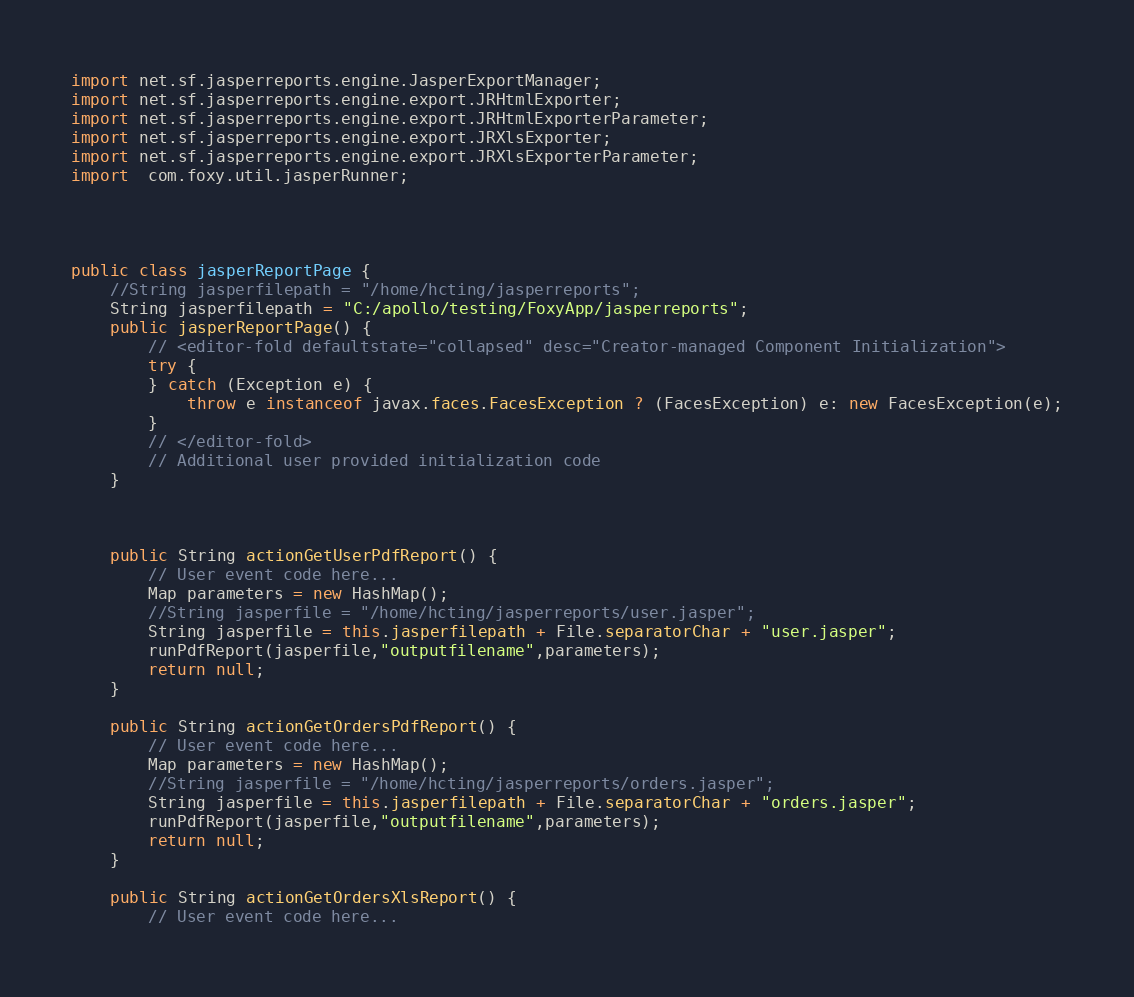<code> <loc_0><loc_0><loc_500><loc_500><_Java_>
import net.sf.jasperreports.engine.JasperExportManager;
import net.sf.jasperreports.engine.export.JRHtmlExporter;
import net.sf.jasperreports.engine.export.JRHtmlExporterParameter;
import net.sf.jasperreports.engine.export.JRXlsExporter;
import net.sf.jasperreports.engine.export.JRXlsExporterParameter;
import  com.foxy.util.jasperRunner;




public class jasperReportPage {
    //String jasperfilepath = "/home/hcting/jasperreports";
    String jasperfilepath = "C:/apollo/testing/FoxyApp/jasperreports";
    public jasperReportPage() {
        // <editor-fold defaultstate="collapsed" desc="Creator-managed Component Initialization">
        try {
        } catch (Exception e) {
            throw e instanceof javax.faces.FacesException ? (FacesException) e: new FacesException(e);
        }
        // </editor-fold>
        // Additional user provided initialization code
    }
    
    
    
    public String actionGetUserPdfReport() {
        // User event code here...
        Map parameters = new HashMap();
        //String jasperfile = "/home/hcting/jasperreports/user.jasper";
        String jasperfile = this.jasperfilepath + File.separatorChar + "user.jasper";
        runPdfReport(jasperfile,"outputfilename",parameters);
        return null;
    }
    
    public String actionGetOrdersPdfReport() {
        // User event code here...
        Map parameters = new HashMap();
        //String jasperfile = "/home/hcting/jasperreports/orders.jasper";
        String jasperfile = this.jasperfilepath + File.separatorChar + "orders.jasper";
        runPdfReport(jasperfile,"outputfilename",parameters);
        return null;
    }
    
    public String actionGetOrdersXlsReport() {
        // User event code here...</code> 